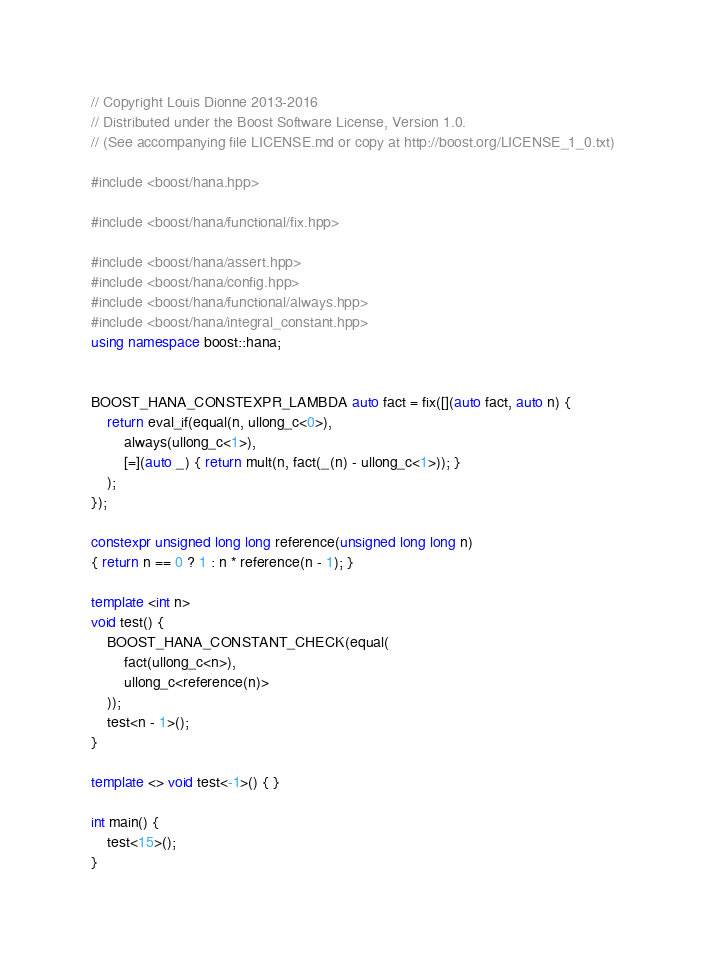Convert code to text. <code><loc_0><loc_0><loc_500><loc_500><_C++_>// Copyright Louis Dionne 2013-2016
// Distributed under the Boost Software License, Version 1.0.
// (See accompanying file LICENSE.md or copy at http://boost.org/LICENSE_1_0.txt)

#include <boost/hana.hpp>

#include <boost/hana/functional/fix.hpp>

#include <boost/hana/assert.hpp>
#include <boost/hana/config.hpp>
#include <boost/hana/functional/always.hpp>
#include <boost/hana/integral_constant.hpp>
using namespace boost::hana;


BOOST_HANA_CONSTEXPR_LAMBDA auto fact = fix([](auto fact, auto n) {
    return eval_if(equal(n, ullong_c<0>),
        always(ullong_c<1>),
        [=](auto _) { return mult(n, fact(_(n) - ullong_c<1>)); }
    );
});

constexpr unsigned long long reference(unsigned long long n)
{ return n == 0 ? 1 : n * reference(n - 1); }

template <int n>
void test() {
    BOOST_HANA_CONSTANT_CHECK(equal(
        fact(ullong_c<n>),
        ullong_c<reference(n)>
    ));
    test<n - 1>();
}

template <> void test<-1>() { }

int main() {
    test<15>();
}
</code> 